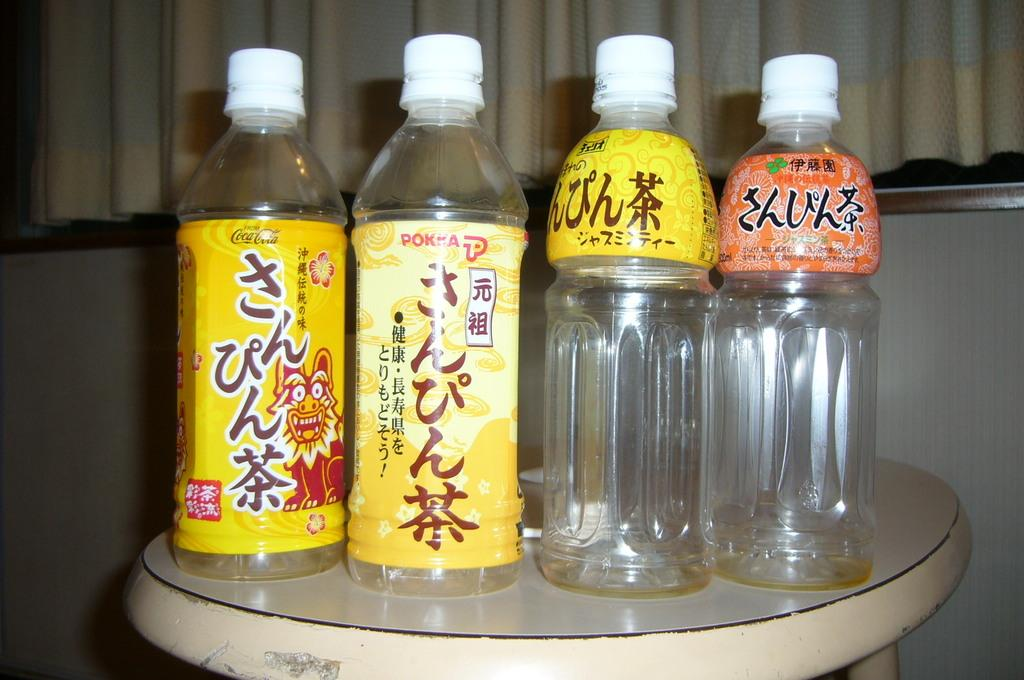Provide a one-sentence caption for the provided image. four bottles of liquid with chinese writing symbols with the first bottle saying cocacola. 